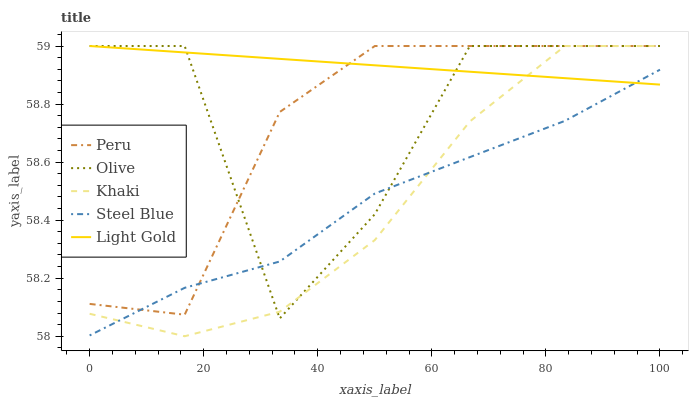Does Light Gold have the minimum area under the curve?
Answer yes or no. No. Does Khaki have the maximum area under the curve?
Answer yes or no. No. Is Khaki the smoothest?
Answer yes or no. No. Is Khaki the roughest?
Answer yes or no. No. Does Light Gold have the lowest value?
Answer yes or no. No. Does Steel Blue have the highest value?
Answer yes or no. No. 